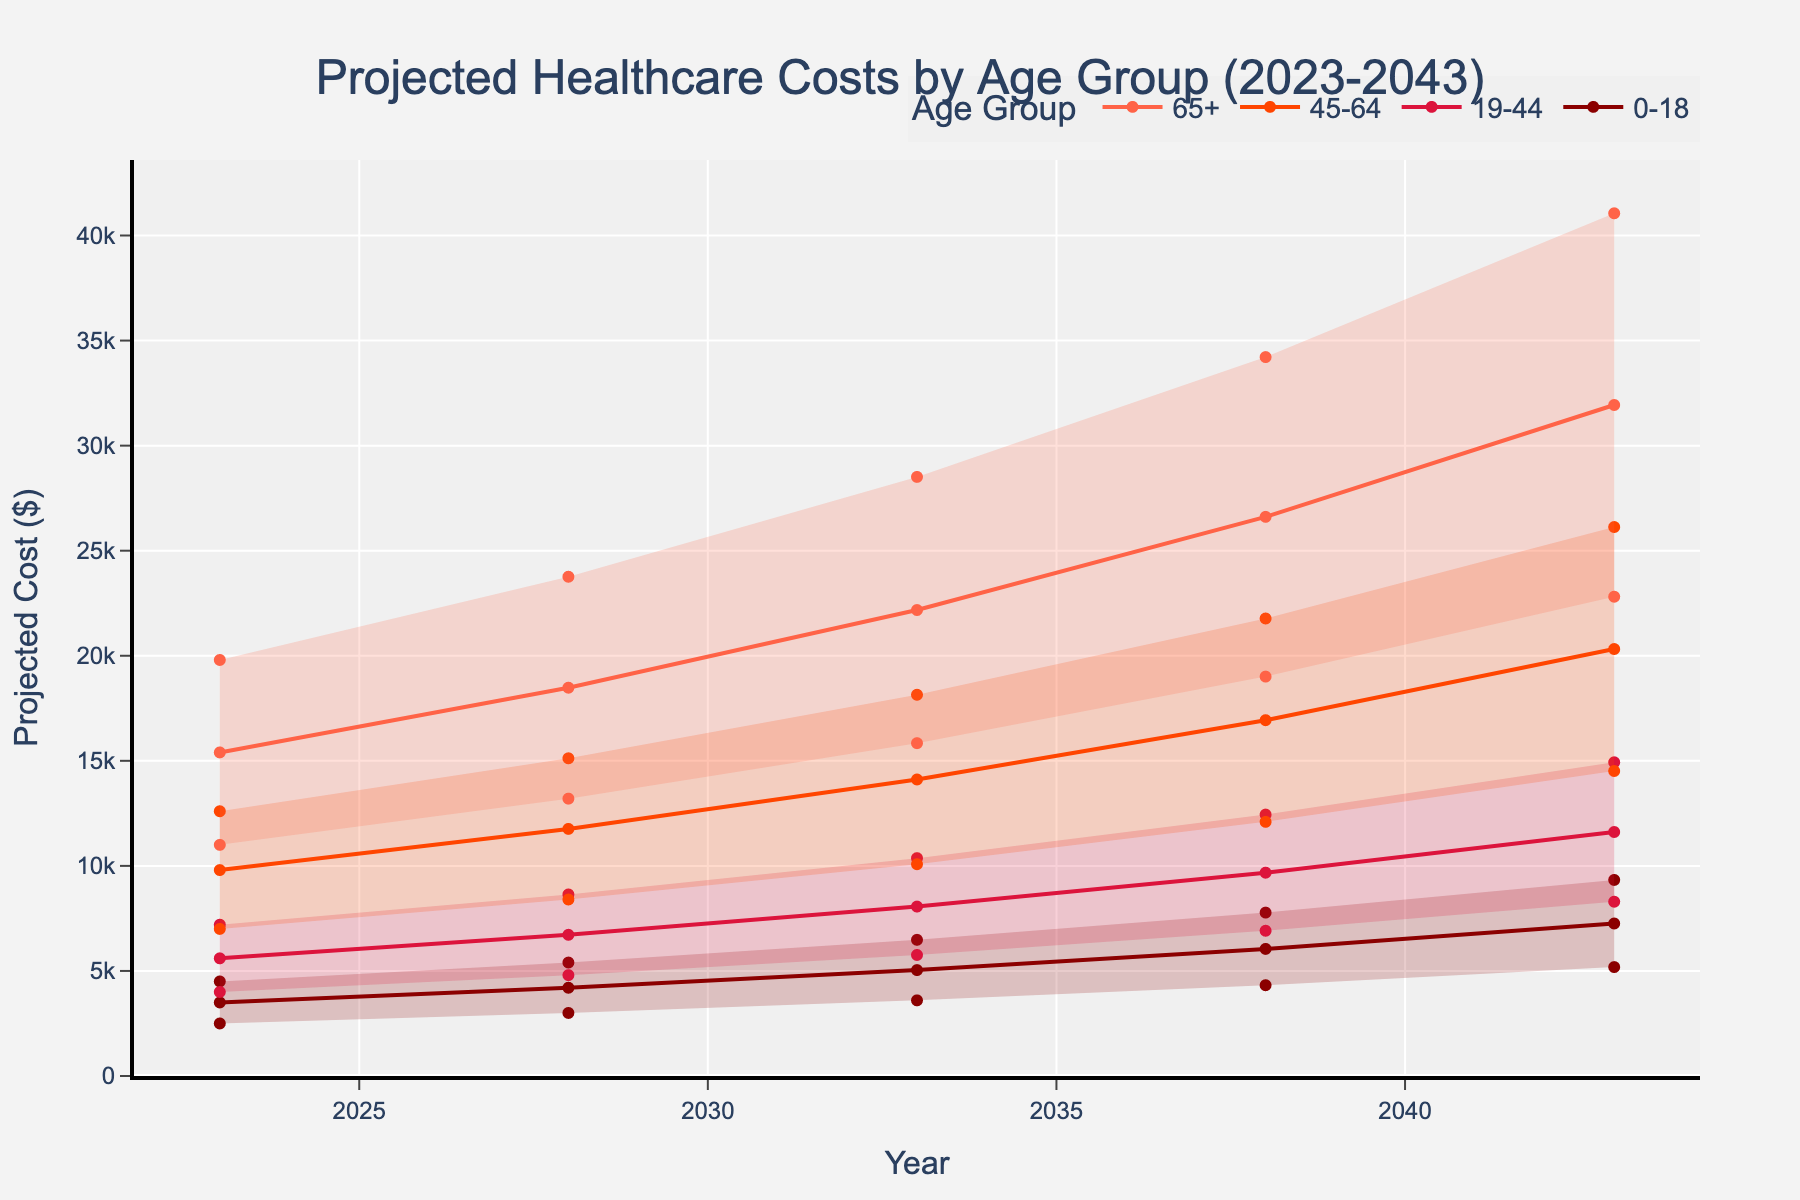What is the title of the figure? The title of a figure is usually placed at the top and provides a summary of what the graph illustrates. The title of this figure is clearly labeled at the top of the plot.
Answer: Projected Healthcare Costs by Age Group (2023-2043) How many age groups are represented in the figure? The different color bands in the chart, each representing a different age group, span across the x-axis. By counting these bands, one can identify the number of groups.
Answer: Four Which year shows the highest projected median healthcare cost for the 65+ age group? To find this, locate the 65+ age group on the chart and observe the median line for that group across the years. Identify the highest point reached by this median line.
Answer: 2043 What is the median projected healthcare cost for the 19-44 age group in 2028? Locate the median line for the 19-44 age group and then find the point corresponding to the year 2028.
Answer: $6,720 By how much is the projected upper bound healthcare cost expected to increase for the 0-18 age group from 2023 to 2043? Compare the upper bound value for the 0-18 age group in 2023 to that in 2043. Calculate the difference between these two values.
Answer: $4,831 Among all age groups, which has the steepest increase in median projected healthcare costs from 2023 to 2043? Examine the slopes of the median lines for all age groups from 2023 to 2043 to determine which has the steepest ascent.
Answer: 65+ In the year 2033, which age group has the smallest range between its lower bound and upper bound projected healthcare costs? For each age group in 2033, subtract the lower bound from the upper bound to find the range. The age group with the smallest range wins.
Answer: 0-18 What is the projected median healthcare cost for the 45-64 age group expected to be in 2038, and how does it compare to the cost in 2028? Find the median projected healthcare cost for the 45-64 age group in 2038 and 2028 from the chart and calculate the difference between them.
Answer: $16,934 in 2038, $11,760 in 2028, difference = $5,174 How does the projected median healthcare cost for the 19-44 age group in 2043 compare to the lower bound of the 45-64 age group in 2043? Locate the median projected healthcare cost for the 19-44 age group in 2043 and compare it to the lower bound value for the 45-64 age group in 2043.
Answer: $11,612 (19-44 median) is less than $14,515 (45-64 lower bound) What is the projected upper bound healthcare cost for the 65+ age group in 2038 and what percentage of the 45-64 age group upper bound cost in the same year is this? Find the upper bound projected cost for both the 65+ age group and the 45-64 age group in 2038. Calculate the percentage by dividing the 65+ value by the 45-64 value and multiplying by 100.
Answer: $34,214 (65+) is approximately 157.26% of $21,773 (45-64) 